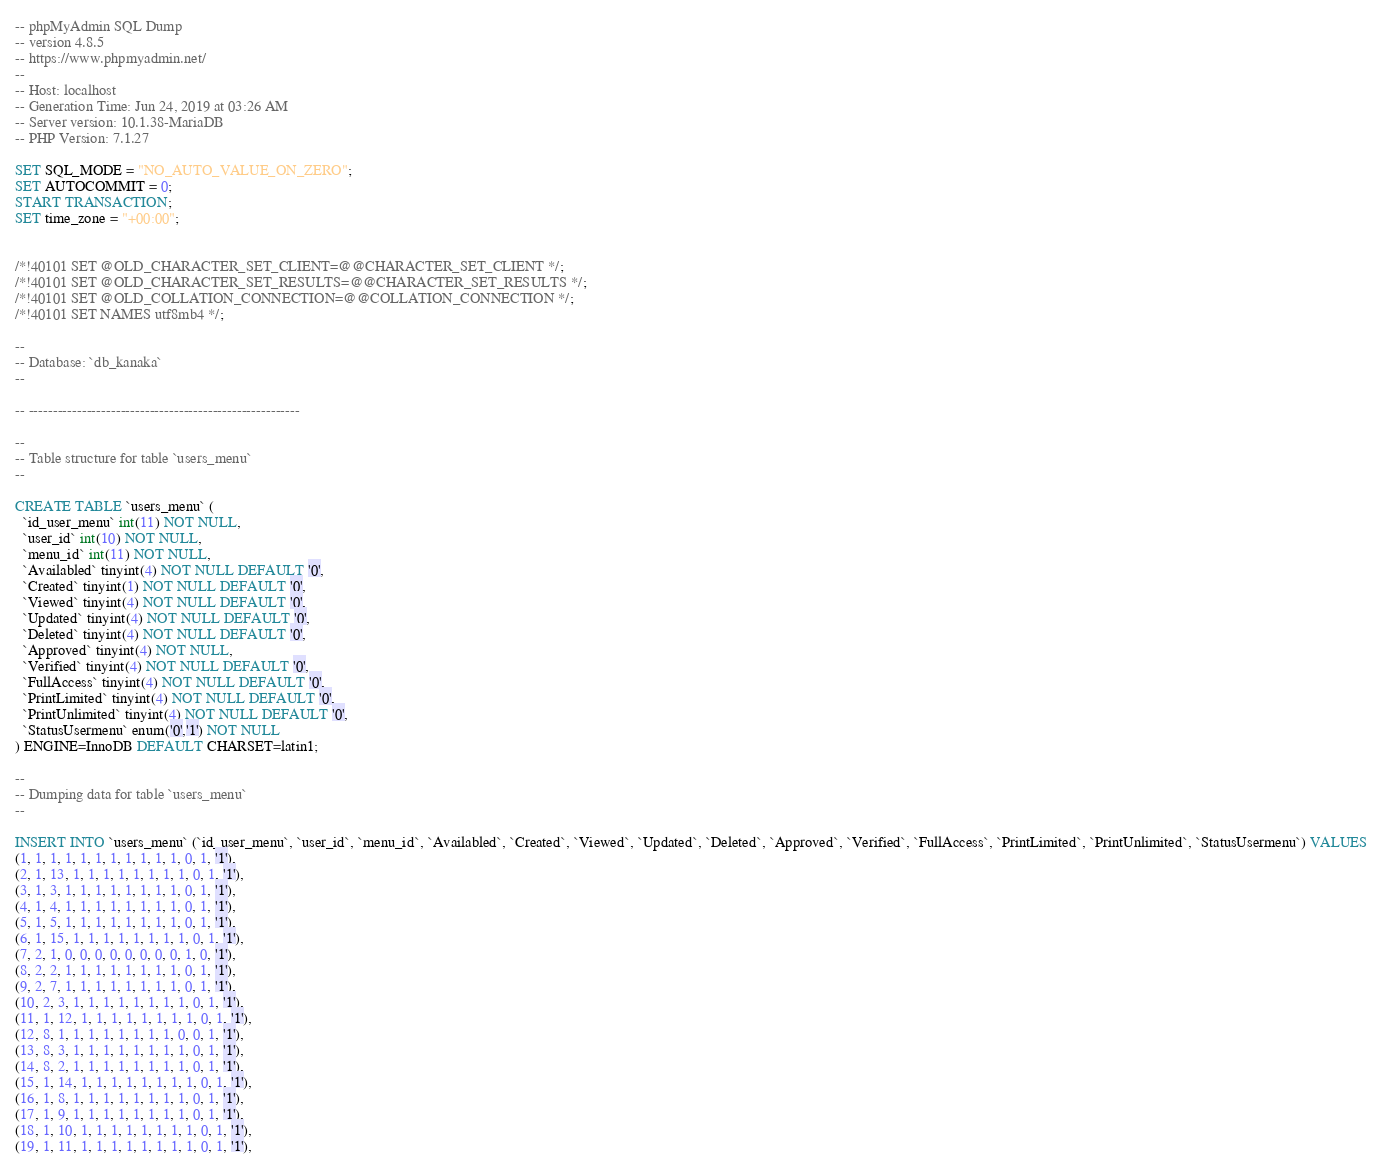<code> <loc_0><loc_0><loc_500><loc_500><_SQL_>-- phpMyAdmin SQL Dump
-- version 4.8.5
-- https://www.phpmyadmin.net/
--
-- Host: localhost
-- Generation Time: Jun 24, 2019 at 03:26 AM
-- Server version: 10.1.38-MariaDB
-- PHP Version: 7.1.27

SET SQL_MODE = "NO_AUTO_VALUE_ON_ZERO";
SET AUTOCOMMIT = 0;
START TRANSACTION;
SET time_zone = "+00:00";


/*!40101 SET @OLD_CHARACTER_SET_CLIENT=@@CHARACTER_SET_CLIENT */;
/*!40101 SET @OLD_CHARACTER_SET_RESULTS=@@CHARACTER_SET_RESULTS */;
/*!40101 SET @OLD_COLLATION_CONNECTION=@@COLLATION_CONNECTION */;
/*!40101 SET NAMES utf8mb4 */;

--
-- Database: `db_kanaka`
--

-- --------------------------------------------------------

--
-- Table structure for table `users_menu`
--

CREATE TABLE `users_menu` (
  `id_user_menu` int(11) NOT NULL,
  `user_id` int(10) NOT NULL,
  `menu_id` int(11) NOT NULL,
  `Availabled` tinyint(4) NOT NULL DEFAULT '0',
  `Created` tinyint(1) NOT NULL DEFAULT '0',
  `Viewed` tinyint(4) NOT NULL DEFAULT '0',
  `Updated` tinyint(4) NOT NULL DEFAULT '0',
  `Deleted` tinyint(4) NOT NULL DEFAULT '0',
  `Approved` tinyint(4) NOT NULL,
  `Verified` tinyint(4) NOT NULL DEFAULT '0',
  `FullAccess` tinyint(4) NOT NULL DEFAULT '0',
  `PrintLimited` tinyint(4) NOT NULL DEFAULT '0',
  `PrintUnlimited` tinyint(4) NOT NULL DEFAULT '0',
  `StatusUsermenu` enum('0','1') NOT NULL
) ENGINE=InnoDB DEFAULT CHARSET=latin1;

--
-- Dumping data for table `users_menu`
--

INSERT INTO `users_menu` (`id_user_menu`, `user_id`, `menu_id`, `Availabled`, `Created`, `Viewed`, `Updated`, `Deleted`, `Approved`, `Verified`, `FullAccess`, `PrintLimited`, `PrintUnlimited`, `StatusUsermenu`) VALUES
(1, 1, 1, 1, 1, 1, 1, 1, 1, 1, 1, 0, 1, '1'),
(2, 1, 13, 1, 1, 1, 1, 1, 1, 1, 1, 0, 1, '1'),
(3, 1, 3, 1, 1, 1, 1, 1, 1, 1, 1, 0, 1, '1'),
(4, 1, 4, 1, 1, 1, 1, 1, 1, 1, 1, 0, 1, '1'),
(5, 1, 5, 1, 1, 1, 1, 1, 1, 1, 1, 0, 1, '1'),
(6, 1, 15, 1, 1, 1, 1, 1, 1, 1, 1, 0, 1, '1'),
(7, 2, 1, 0, 0, 0, 0, 0, 0, 0, 0, 1, 0, '1'),
(8, 2, 2, 1, 1, 1, 1, 1, 1, 1, 1, 0, 1, '1'),
(9, 2, 7, 1, 1, 1, 1, 1, 1, 1, 1, 0, 1, '1'),
(10, 2, 3, 1, 1, 1, 1, 1, 1, 1, 1, 0, 1, '1'),
(11, 1, 12, 1, 1, 1, 1, 1, 1, 1, 1, 0, 1, '1'),
(12, 8, 1, 1, 1, 1, 1, 1, 1, 1, 0, 0, 1, '1'),
(13, 8, 3, 1, 1, 1, 1, 1, 1, 1, 1, 0, 1, '1'),
(14, 8, 2, 1, 1, 1, 1, 1, 1, 1, 1, 0, 1, '1'),
(15, 1, 14, 1, 1, 1, 1, 1, 1, 1, 1, 0, 1, '1'),
(16, 1, 8, 1, 1, 1, 1, 1, 1, 1, 1, 0, 1, '1'),
(17, 1, 9, 1, 1, 1, 1, 1, 1, 1, 1, 0, 1, '1'),
(18, 1, 10, 1, 1, 1, 1, 1, 1, 1, 1, 0, 1, '1'),
(19, 1, 11, 1, 1, 1, 1, 1, 1, 1, 1, 0, 1, '1'),</code> 